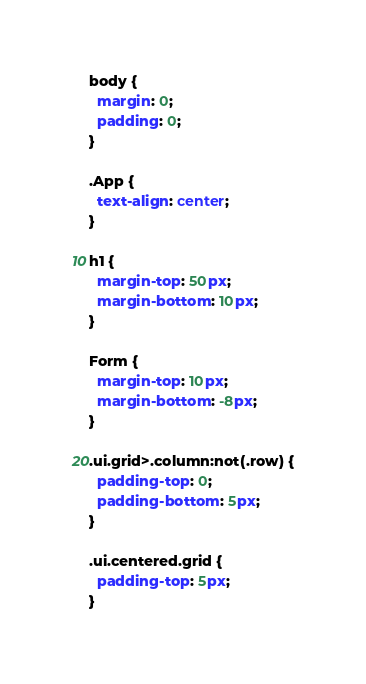<code> <loc_0><loc_0><loc_500><loc_500><_CSS_>body {
  margin: 0;
  padding: 0;
}

.App {
  text-align: center;
}

h1 {
  margin-top: 50px;
  margin-bottom: 10px;
}

Form {
  margin-top: 10px;
  margin-bottom: -8px;
}

.ui.grid>.column:not(.row) {
  padding-top: 0;
  padding-bottom: 5px;
}

.ui.centered.grid {
  padding-top: 5px;
}

</code> 